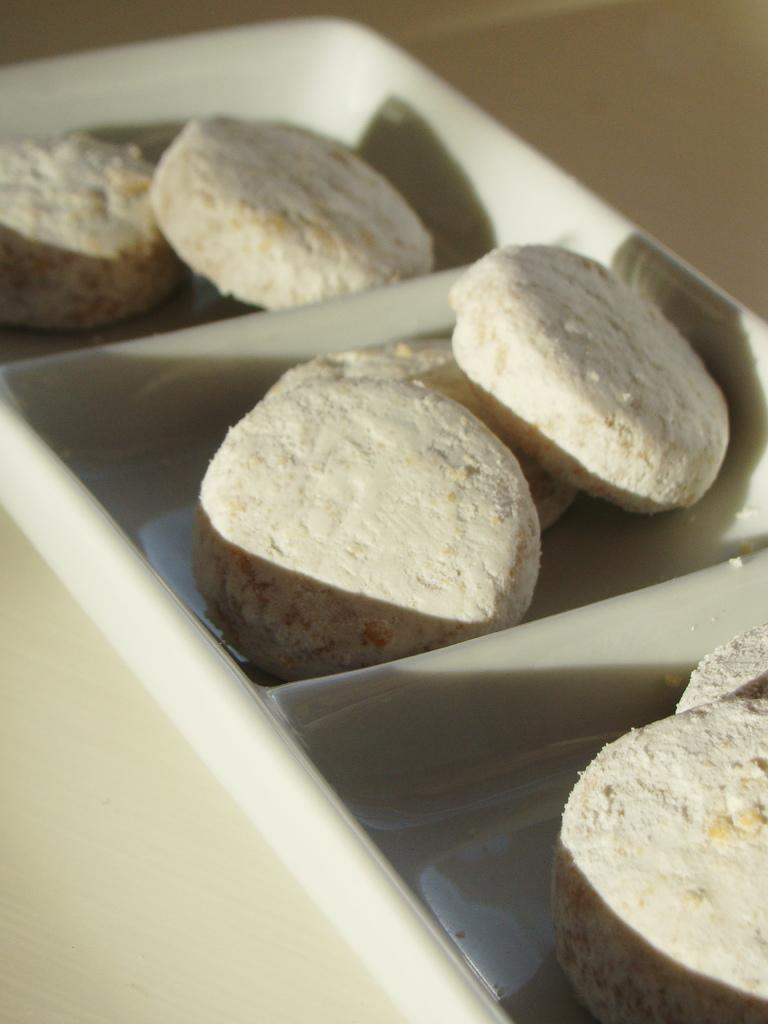What type of food can be seen in the image? There are cookies in the image. What is the color of the cookies? The cookies are white in color. How are the cookies arranged in the image? The cookies are kept in a tray. What piece of furniture is visible at the bottom of the image? There is a table visible at the bottom of the image. How many eyes can be seen on the cookies in the image? There are no eyes visible on the cookies in the image, as they are inanimate objects. 